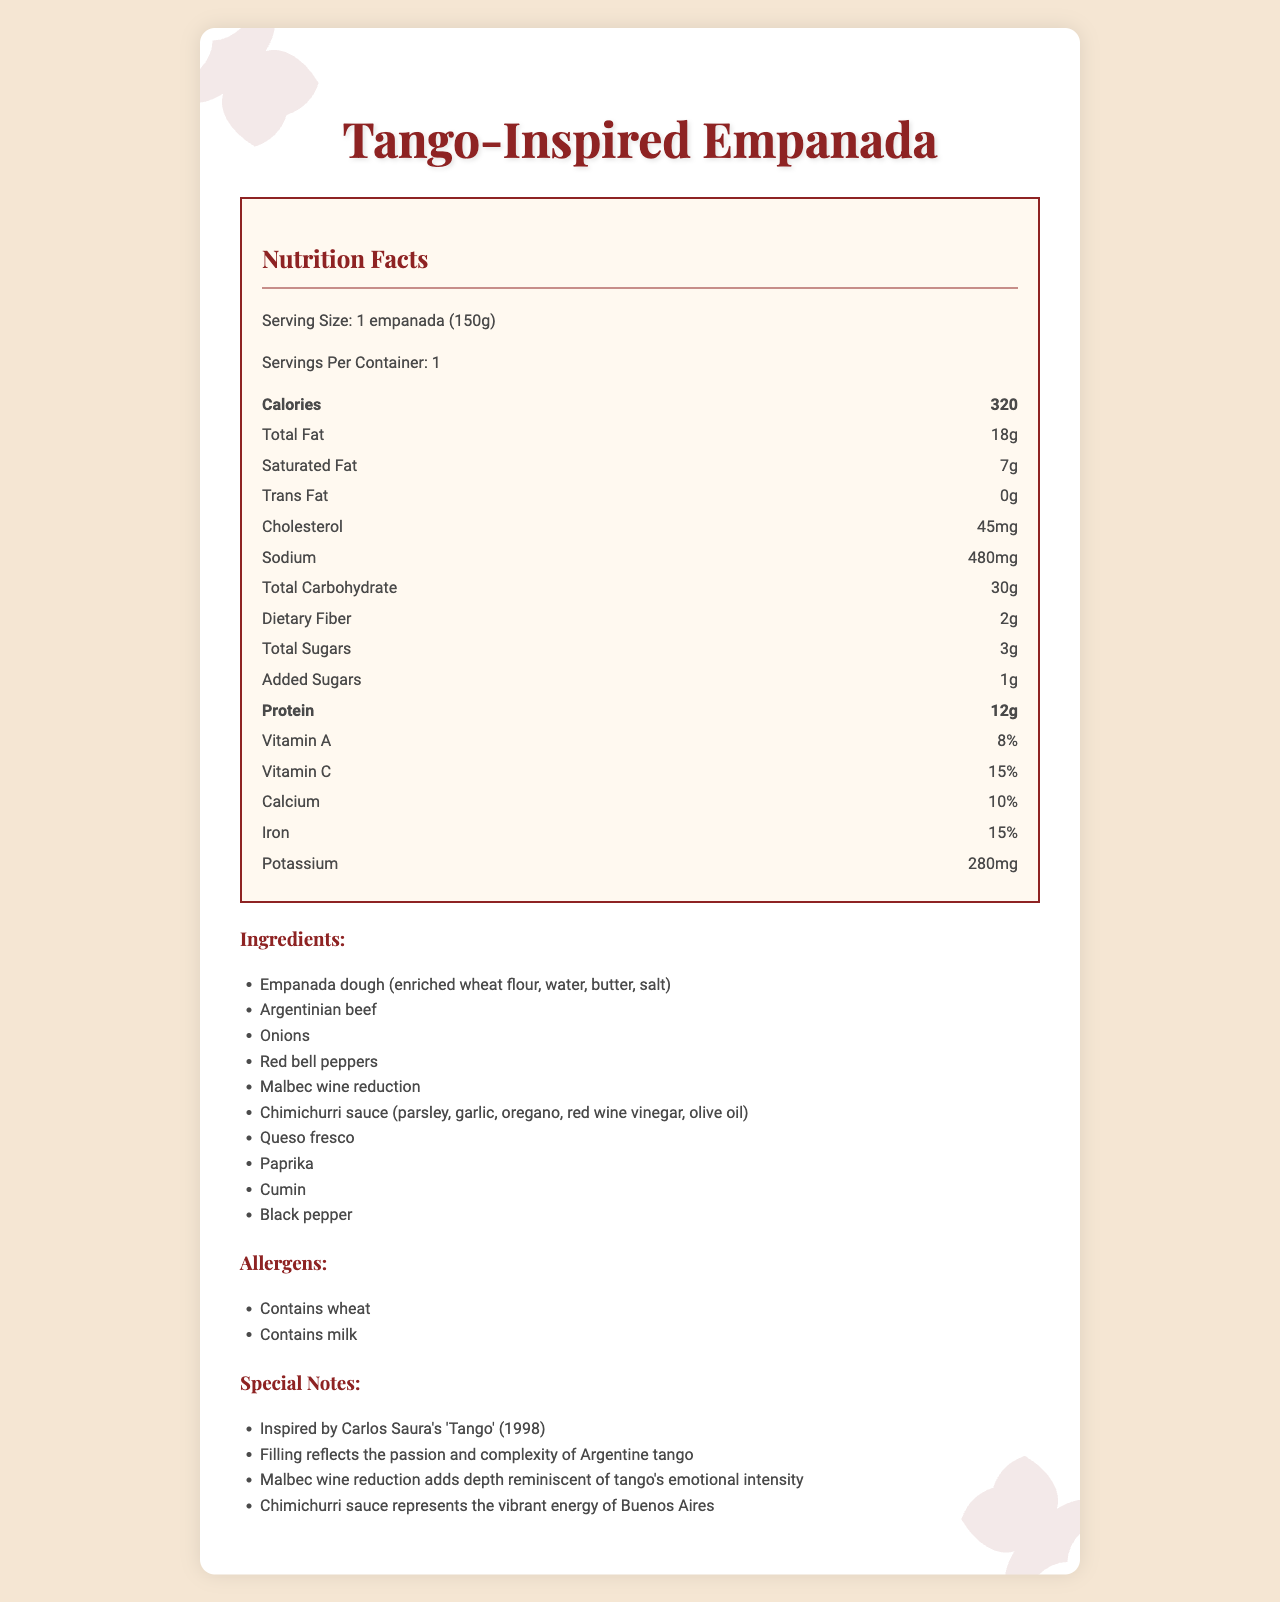what is the serving size? The serving size is provided at the top of the Nutrition Facts section.
Answer: 1 empanada (150g) how many calories does one empanada have? The number of calories per serving is clearly listed.
Answer: 320 how much total fat is in one empanada? The total fat content is listed in the Nutrition Facts section.
Answer: 18g how much sodium is in one empanada? The sodium content is specified in the Nutrition Facts section.
Answer: 480mg what are the main ingredients? The main ingredients are listed under the Ingredients section.
Answer: Empanada dough, Argentinian beef, onions, red bell peppers, Malbec wine reduction, chimichurri sauce, queso fresco, paprika, cumin, black pepper how much protein is in one empanada? A. 10g B. 12g C. 14g The protein content is listed in the Nutrition Facts section.
Answer: B. 12g what percentage of vitamin A is provided? A. 5% B. 8% C. 12% The percentage of Vitamin A is mentioned in the Nutrition Facts section.
Answer: B. 8% is there any trans fat in the empanada? The document states that the trans fat content is 0g.
Answer: No does this empanada contain milk? The Allergens section indicates that the empanada contains milk.
Answer: Yes summarize the main idea of the document. The document provides a comprehensive overview of the nutritional content and ingredient composition of the empanada, as well as highlighting the tango-inspired elements in its preparation.
Answer: The document describes the nutrition facts and ingredients of a tango-inspired gourmet empanada. It provides detailed nutritional information, lists the ingredients, mentions allergens, and includes special notes connecting the empanada's flavors to the elements of tango. what inspired the filling of the empanada? The Special Notes section mentions the inspiration behind the empanada's filling.
Answer: Carlos Saura's 'Tango' (1998) how much dietary fiber is in one empanada? The dietary fiber content is listed in the Nutrition Facts section.
Answer: 2g what effect does the Malbec wine reduction have? The Special Notes section explains the impact of the Malbec wine reduction.
Answer: Adds depth reminiscent of tango's emotional intensity how much potassium is in one empanada? The potassium content is provided in the Nutrition Facts section.
Answer: 280mg can you determine the exact Malbec wine used in the empanada? The document provides general information about the ingredients but does not specify the exact brand or type of Malbec wine used.
Answer: Cannot be determined 